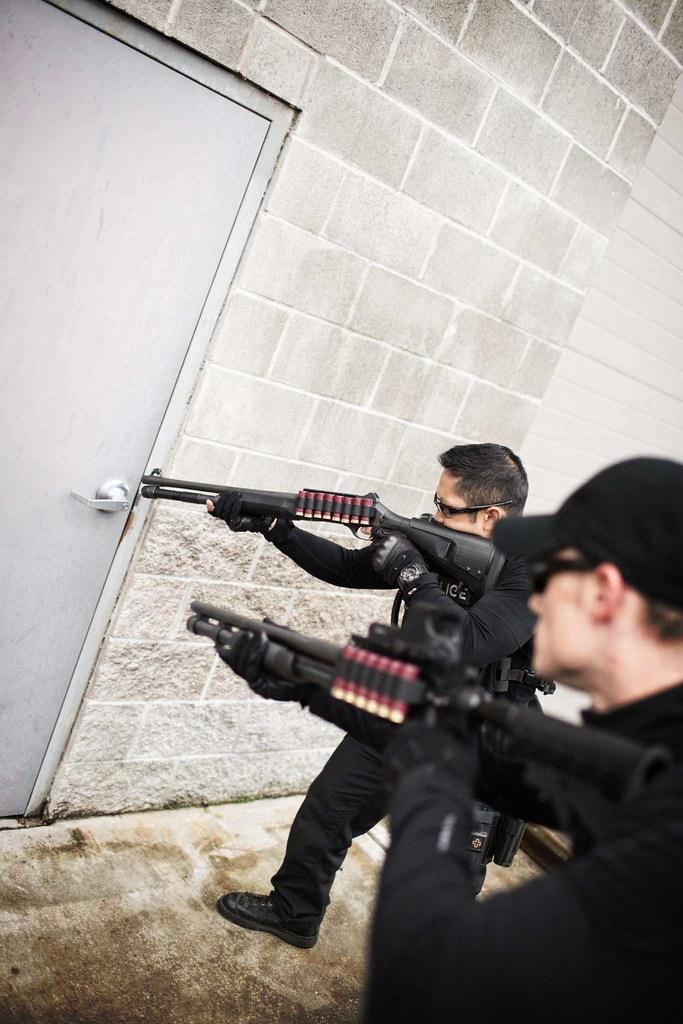How would you summarize this image in a sentence or two? On the right side of the image there are two men standing and holding guns in their hands. And there is a man with a cap on his head. In front of them there is a wall with a door. 